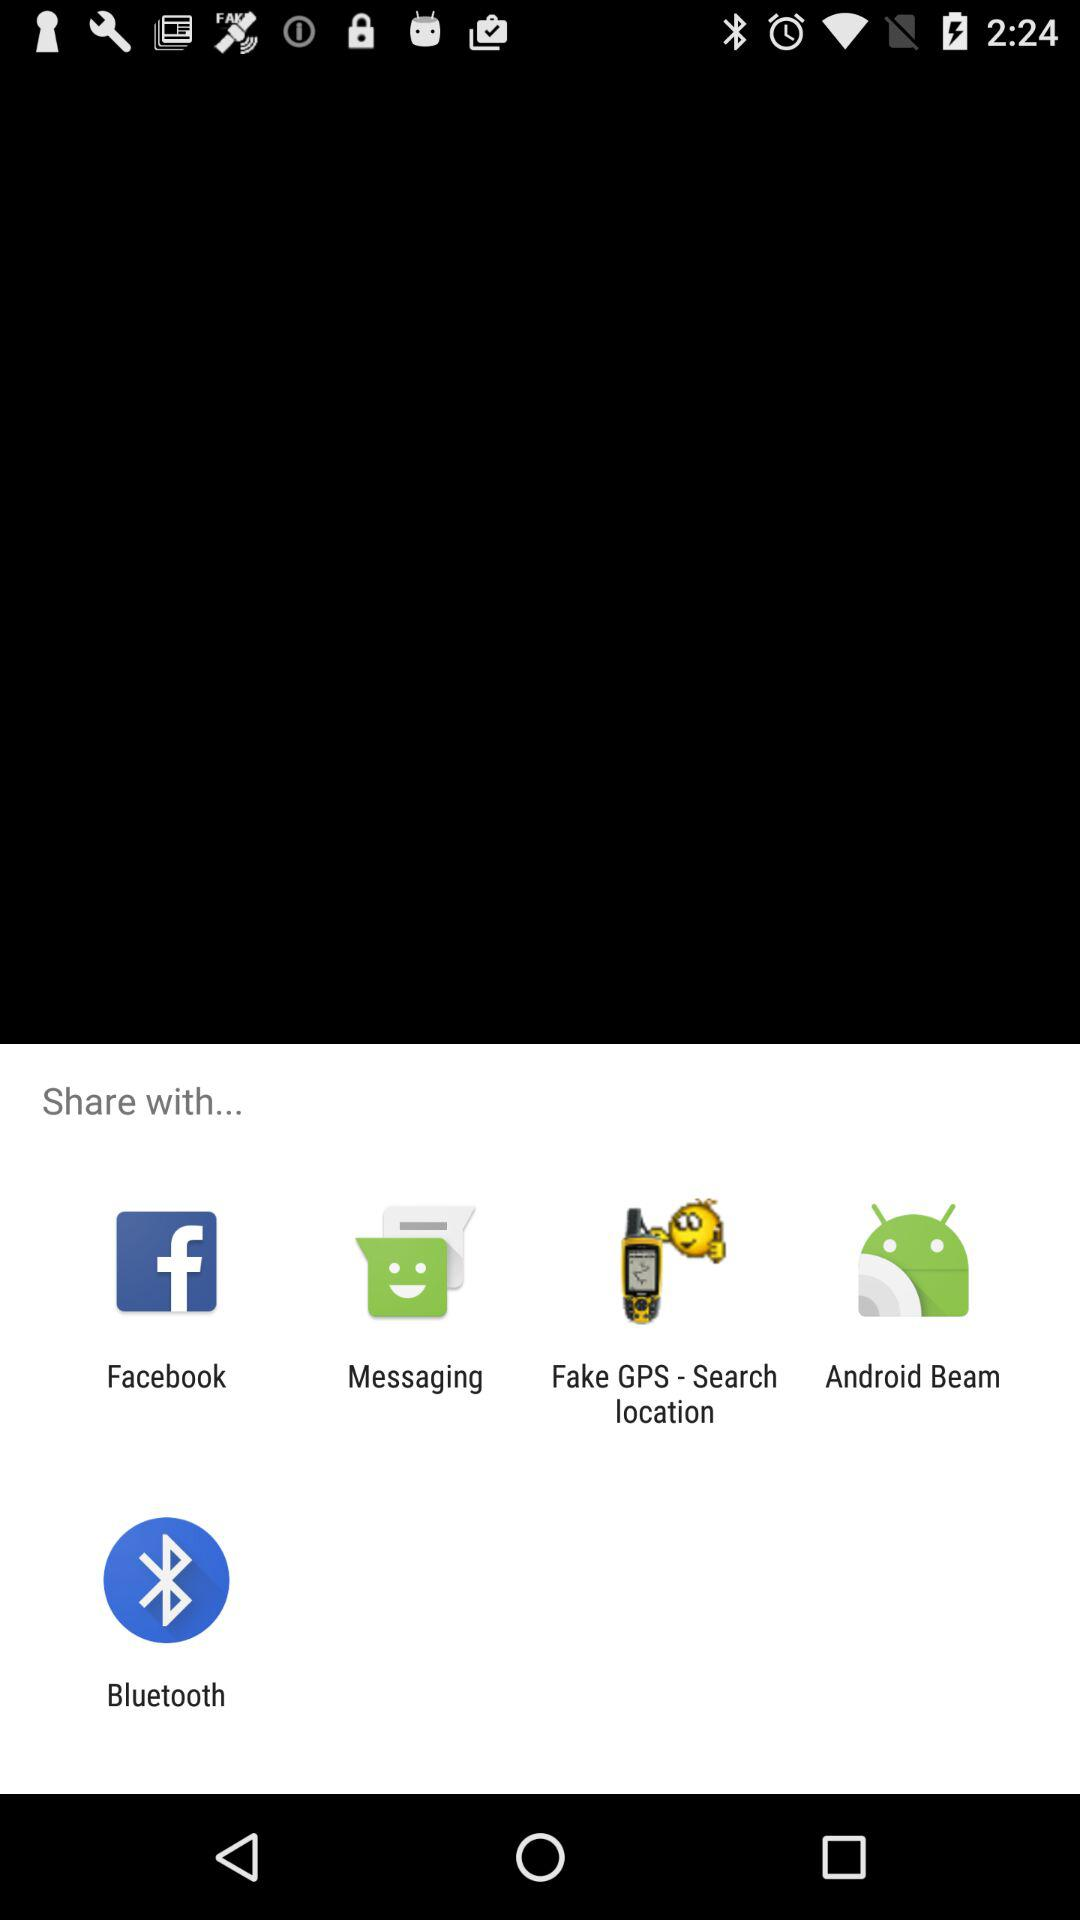Who is sharing the content?
When the provided information is insufficient, respond with <no answer>. <no answer> 